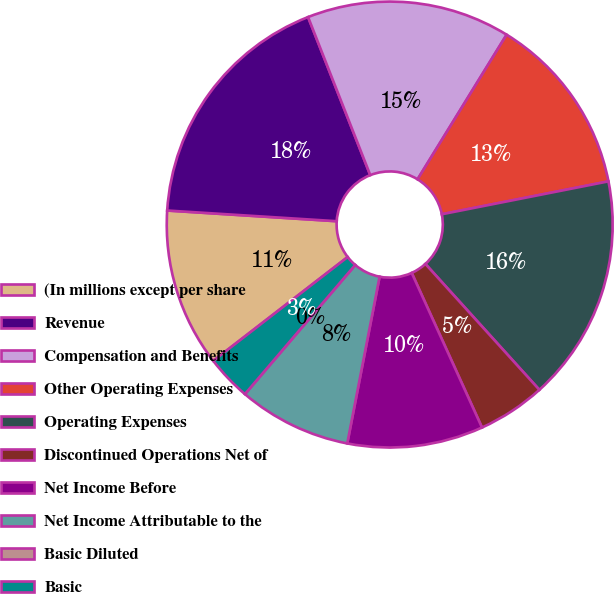Convert chart. <chart><loc_0><loc_0><loc_500><loc_500><pie_chart><fcel>(In millions except per share<fcel>Revenue<fcel>Compensation and Benefits<fcel>Other Operating Expenses<fcel>Operating Expenses<fcel>Discontinued Operations Net of<fcel>Net Income Before<fcel>Net Income Attributable to the<fcel>Basic Diluted<fcel>Basic<nl><fcel>11.47%<fcel>18.03%<fcel>14.75%<fcel>13.11%<fcel>16.39%<fcel>4.92%<fcel>9.84%<fcel>8.2%<fcel>0.0%<fcel>3.28%<nl></chart> 